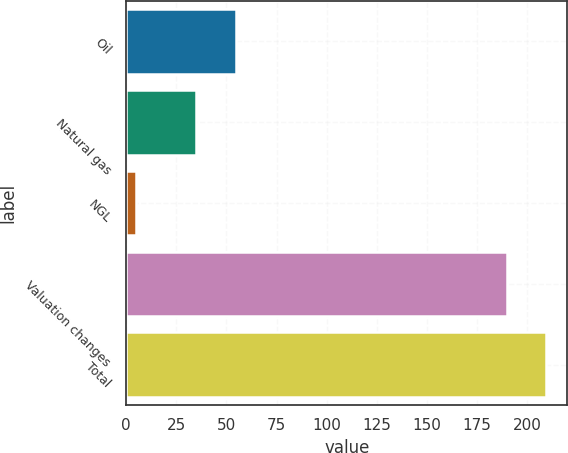Convert chart. <chart><loc_0><loc_0><loc_500><loc_500><bar_chart><fcel>Oil<fcel>Natural gas<fcel>NGL<fcel>Valuation changes<fcel>Total<nl><fcel>54.6<fcel>35<fcel>5<fcel>190<fcel>209.6<nl></chart> 